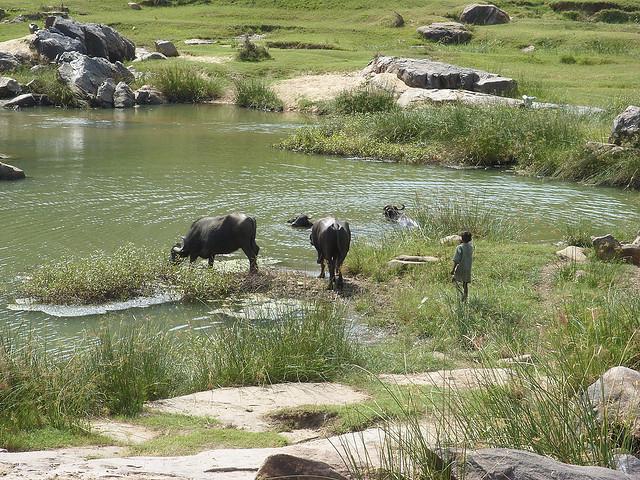How many animals are there?
Give a very brief answer. 2. How many cows are in the photo?
Give a very brief answer. 2. 